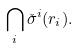<formula> <loc_0><loc_0><loc_500><loc_500>\bigcap _ { i } \check { \sigma } ^ { i } ( r _ { i } ) .</formula> 